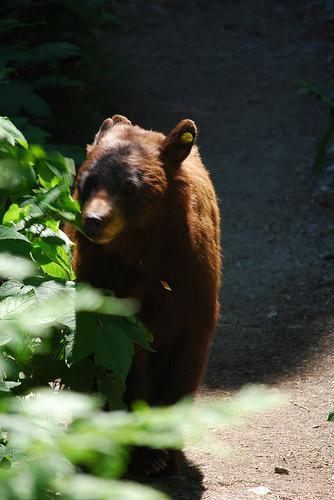Question: what animal is this?
Choices:
A. A dog.
B. A bear.
C. A cat.
D. A horse.
Answer with the letter. Answer: B Question: what is on the bear's right?
Choices:
A. A tree.
B. A pond.
C. A river.
D. A bush.
Answer with the letter. Answer: D 